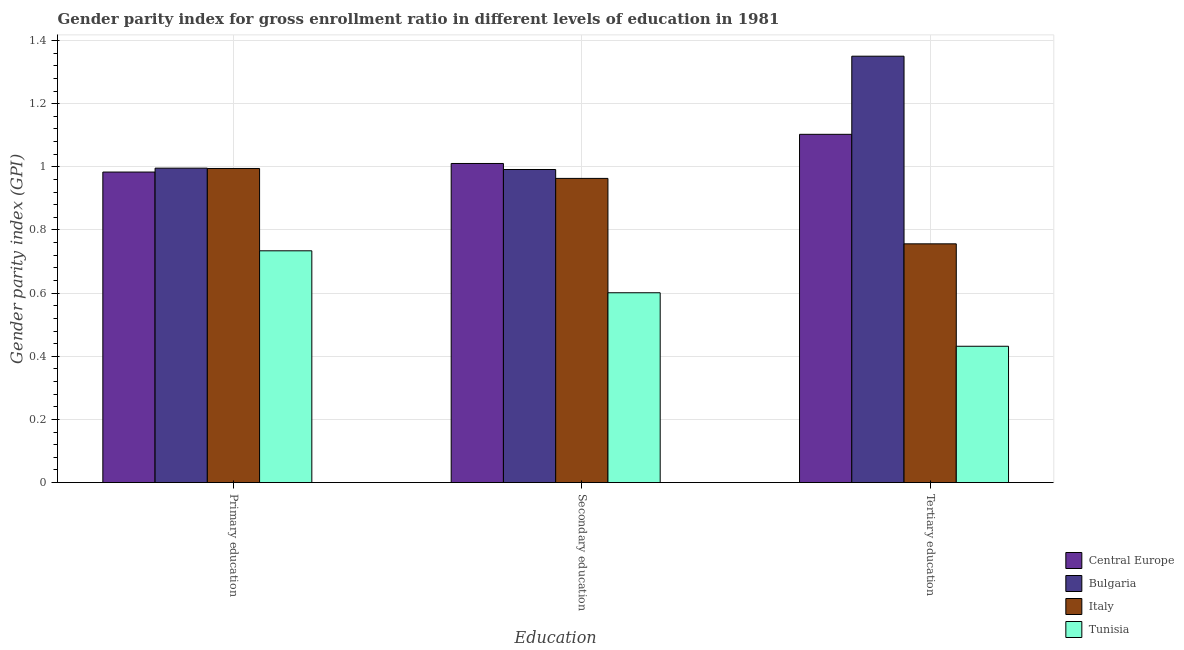How many groups of bars are there?
Provide a succinct answer. 3. Are the number of bars per tick equal to the number of legend labels?
Your answer should be very brief. Yes. How many bars are there on the 3rd tick from the left?
Keep it short and to the point. 4. What is the label of the 3rd group of bars from the left?
Your answer should be very brief. Tertiary education. What is the gender parity index in primary education in Tunisia?
Provide a short and direct response. 0.73. Across all countries, what is the maximum gender parity index in primary education?
Ensure brevity in your answer.  1. Across all countries, what is the minimum gender parity index in tertiary education?
Make the answer very short. 0.43. In which country was the gender parity index in tertiary education minimum?
Provide a succinct answer. Tunisia. What is the total gender parity index in primary education in the graph?
Your answer should be compact. 3.71. What is the difference between the gender parity index in secondary education in Italy and that in Bulgaria?
Offer a terse response. -0.03. What is the difference between the gender parity index in primary education in Bulgaria and the gender parity index in tertiary education in Tunisia?
Your answer should be very brief. 0.56. What is the average gender parity index in tertiary education per country?
Ensure brevity in your answer.  0.91. What is the difference between the gender parity index in tertiary education and gender parity index in primary education in Bulgaria?
Make the answer very short. 0.35. In how many countries, is the gender parity index in secondary education greater than 0.6400000000000001 ?
Offer a terse response. 3. What is the ratio of the gender parity index in tertiary education in Tunisia to that in Italy?
Your answer should be compact. 0.57. Is the difference between the gender parity index in secondary education in Italy and Tunisia greater than the difference between the gender parity index in tertiary education in Italy and Tunisia?
Your answer should be very brief. Yes. What is the difference between the highest and the second highest gender parity index in primary education?
Offer a very short reply. 0. What is the difference between the highest and the lowest gender parity index in primary education?
Your answer should be very brief. 0.26. In how many countries, is the gender parity index in secondary education greater than the average gender parity index in secondary education taken over all countries?
Ensure brevity in your answer.  3. Is the sum of the gender parity index in secondary education in Tunisia and Central Europe greater than the maximum gender parity index in primary education across all countries?
Provide a short and direct response. Yes. What does the 4th bar from the left in Secondary education represents?
Give a very brief answer. Tunisia. What does the 4th bar from the right in Secondary education represents?
Your response must be concise. Central Europe. Is it the case that in every country, the sum of the gender parity index in primary education and gender parity index in secondary education is greater than the gender parity index in tertiary education?
Offer a very short reply. Yes. Are the values on the major ticks of Y-axis written in scientific E-notation?
Offer a terse response. No. Does the graph contain any zero values?
Keep it short and to the point. No. Where does the legend appear in the graph?
Ensure brevity in your answer.  Bottom right. How are the legend labels stacked?
Offer a very short reply. Vertical. What is the title of the graph?
Make the answer very short. Gender parity index for gross enrollment ratio in different levels of education in 1981. Does "Norway" appear as one of the legend labels in the graph?
Provide a succinct answer. No. What is the label or title of the X-axis?
Offer a very short reply. Education. What is the label or title of the Y-axis?
Provide a succinct answer. Gender parity index (GPI). What is the Gender parity index (GPI) in Central Europe in Primary education?
Keep it short and to the point. 0.98. What is the Gender parity index (GPI) in Bulgaria in Primary education?
Provide a short and direct response. 1. What is the Gender parity index (GPI) in Italy in Primary education?
Keep it short and to the point. 0.99. What is the Gender parity index (GPI) of Tunisia in Primary education?
Make the answer very short. 0.73. What is the Gender parity index (GPI) of Central Europe in Secondary education?
Make the answer very short. 1.01. What is the Gender parity index (GPI) in Bulgaria in Secondary education?
Your answer should be compact. 0.99. What is the Gender parity index (GPI) in Italy in Secondary education?
Ensure brevity in your answer.  0.96. What is the Gender parity index (GPI) of Tunisia in Secondary education?
Offer a terse response. 0.6. What is the Gender parity index (GPI) of Central Europe in Tertiary education?
Your answer should be very brief. 1.1. What is the Gender parity index (GPI) in Bulgaria in Tertiary education?
Your answer should be very brief. 1.35. What is the Gender parity index (GPI) in Italy in Tertiary education?
Keep it short and to the point. 0.76. What is the Gender parity index (GPI) of Tunisia in Tertiary education?
Ensure brevity in your answer.  0.43. Across all Education, what is the maximum Gender parity index (GPI) of Central Europe?
Offer a very short reply. 1.1. Across all Education, what is the maximum Gender parity index (GPI) in Bulgaria?
Ensure brevity in your answer.  1.35. Across all Education, what is the maximum Gender parity index (GPI) of Tunisia?
Your response must be concise. 0.73. Across all Education, what is the minimum Gender parity index (GPI) of Central Europe?
Provide a succinct answer. 0.98. Across all Education, what is the minimum Gender parity index (GPI) in Bulgaria?
Ensure brevity in your answer.  0.99. Across all Education, what is the minimum Gender parity index (GPI) of Italy?
Your response must be concise. 0.76. Across all Education, what is the minimum Gender parity index (GPI) in Tunisia?
Provide a succinct answer. 0.43. What is the total Gender parity index (GPI) of Central Europe in the graph?
Your response must be concise. 3.1. What is the total Gender parity index (GPI) in Bulgaria in the graph?
Offer a terse response. 3.34. What is the total Gender parity index (GPI) in Italy in the graph?
Give a very brief answer. 2.71. What is the total Gender parity index (GPI) of Tunisia in the graph?
Provide a short and direct response. 1.77. What is the difference between the Gender parity index (GPI) in Central Europe in Primary education and that in Secondary education?
Provide a succinct answer. -0.03. What is the difference between the Gender parity index (GPI) of Bulgaria in Primary education and that in Secondary education?
Your response must be concise. 0. What is the difference between the Gender parity index (GPI) in Italy in Primary education and that in Secondary education?
Your answer should be very brief. 0.03. What is the difference between the Gender parity index (GPI) of Tunisia in Primary education and that in Secondary education?
Offer a terse response. 0.13. What is the difference between the Gender parity index (GPI) in Central Europe in Primary education and that in Tertiary education?
Ensure brevity in your answer.  -0.12. What is the difference between the Gender parity index (GPI) in Bulgaria in Primary education and that in Tertiary education?
Your response must be concise. -0.35. What is the difference between the Gender parity index (GPI) in Italy in Primary education and that in Tertiary education?
Provide a succinct answer. 0.24. What is the difference between the Gender parity index (GPI) of Tunisia in Primary education and that in Tertiary education?
Ensure brevity in your answer.  0.3. What is the difference between the Gender parity index (GPI) in Central Europe in Secondary education and that in Tertiary education?
Keep it short and to the point. -0.09. What is the difference between the Gender parity index (GPI) in Bulgaria in Secondary education and that in Tertiary education?
Offer a very short reply. -0.36. What is the difference between the Gender parity index (GPI) in Italy in Secondary education and that in Tertiary education?
Your answer should be compact. 0.21. What is the difference between the Gender parity index (GPI) in Tunisia in Secondary education and that in Tertiary education?
Provide a short and direct response. 0.17. What is the difference between the Gender parity index (GPI) in Central Europe in Primary education and the Gender parity index (GPI) in Bulgaria in Secondary education?
Provide a short and direct response. -0.01. What is the difference between the Gender parity index (GPI) of Central Europe in Primary education and the Gender parity index (GPI) of Italy in Secondary education?
Give a very brief answer. 0.02. What is the difference between the Gender parity index (GPI) in Central Europe in Primary education and the Gender parity index (GPI) in Tunisia in Secondary education?
Your answer should be very brief. 0.38. What is the difference between the Gender parity index (GPI) in Bulgaria in Primary education and the Gender parity index (GPI) in Italy in Secondary education?
Provide a short and direct response. 0.03. What is the difference between the Gender parity index (GPI) of Bulgaria in Primary education and the Gender parity index (GPI) of Tunisia in Secondary education?
Make the answer very short. 0.39. What is the difference between the Gender parity index (GPI) in Italy in Primary education and the Gender parity index (GPI) in Tunisia in Secondary education?
Give a very brief answer. 0.39. What is the difference between the Gender parity index (GPI) in Central Europe in Primary education and the Gender parity index (GPI) in Bulgaria in Tertiary education?
Your answer should be compact. -0.37. What is the difference between the Gender parity index (GPI) in Central Europe in Primary education and the Gender parity index (GPI) in Italy in Tertiary education?
Make the answer very short. 0.23. What is the difference between the Gender parity index (GPI) of Central Europe in Primary education and the Gender parity index (GPI) of Tunisia in Tertiary education?
Keep it short and to the point. 0.55. What is the difference between the Gender parity index (GPI) in Bulgaria in Primary education and the Gender parity index (GPI) in Italy in Tertiary education?
Give a very brief answer. 0.24. What is the difference between the Gender parity index (GPI) in Bulgaria in Primary education and the Gender parity index (GPI) in Tunisia in Tertiary education?
Keep it short and to the point. 0.56. What is the difference between the Gender parity index (GPI) of Italy in Primary education and the Gender parity index (GPI) of Tunisia in Tertiary education?
Your answer should be compact. 0.56. What is the difference between the Gender parity index (GPI) in Central Europe in Secondary education and the Gender parity index (GPI) in Bulgaria in Tertiary education?
Your response must be concise. -0.34. What is the difference between the Gender parity index (GPI) in Central Europe in Secondary education and the Gender parity index (GPI) in Italy in Tertiary education?
Offer a terse response. 0.25. What is the difference between the Gender parity index (GPI) in Central Europe in Secondary education and the Gender parity index (GPI) in Tunisia in Tertiary education?
Ensure brevity in your answer.  0.58. What is the difference between the Gender parity index (GPI) of Bulgaria in Secondary education and the Gender parity index (GPI) of Italy in Tertiary education?
Offer a very short reply. 0.24. What is the difference between the Gender parity index (GPI) of Bulgaria in Secondary education and the Gender parity index (GPI) of Tunisia in Tertiary education?
Offer a very short reply. 0.56. What is the difference between the Gender parity index (GPI) of Italy in Secondary education and the Gender parity index (GPI) of Tunisia in Tertiary education?
Offer a terse response. 0.53. What is the average Gender parity index (GPI) of Central Europe per Education?
Give a very brief answer. 1.03. What is the average Gender parity index (GPI) of Bulgaria per Education?
Keep it short and to the point. 1.11. What is the average Gender parity index (GPI) of Italy per Education?
Offer a very short reply. 0.9. What is the average Gender parity index (GPI) in Tunisia per Education?
Keep it short and to the point. 0.59. What is the difference between the Gender parity index (GPI) in Central Europe and Gender parity index (GPI) in Bulgaria in Primary education?
Make the answer very short. -0.01. What is the difference between the Gender parity index (GPI) of Central Europe and Gender parity index (GPI) of Italy in Primary education?
Give a very brief answer. -0.01. What is the difference between the Gender parity index (GPI) of Central Europe and Gender parity index (GPI) of Tunisia in Primary education?
Keep it short and to the point. 0.25. What is the difference between the Gender parity index (GPI) in Bulgaria and Gender parity index (GPI) in Italy in Primary education?
Your answer should be very brief. 0. What is the difference between the Gender parity index (GPI) in Bulgaria and Gender parity index (GPI) in Tunisia in Primary education?
Keep it short and to the point. 0.26. What is the difference between the Gender parity index (GPI) of Italy and Gender parity index (GPI) of Tunisia in Primary education?
Make the answer very short. 0.26. What is the difference between the Gender parity index (GPI) in Central Europe and Gender parity index (GPI) in Bulgaria in Secondary education?
Provide a short and direct response. 0.02. What is the difference between the Gender parity index (GPI) of Central Europe and Gender parity index (GPI) of Italy in Secondary education?
Provide a short and direct response. 0.05. What is the difference between the Gender parity index (GPI) of Central Europe and Gender parity index (GPI) of Tunisia in Secondary education?
Offer a very short reply. 0.41. What is the difference between the Gender parity index (GPI) in Bulgaria and Gender parity index (GPI) in Italy in Secondary education?
Your answer should be very brief. 0.03. What is the difference between the Gender parity index (GPI) of Bulgaria and Gender parity index (GPI) of Tunisia in Secondary education?
Provide a short and direct response. 0.39. What is the difference between the Gender parity index (GPI) of Italy and Gender parity index (GPI) of Tunisia in Secondary education?
Your answer should be very brief. 0.36. What is the difference between the Gender parity index (GPI) of Central Europe and Gender parity index (GPI) of Bulgaria in Tertiary education?
Your answer should be compact. -0.25. What is the difference between the Gender parity index (GPI) in Central Europe and Gender parity index (GPI) in Italy in Tertiary education?
Offer a terse response. 0.35. What is the difference between the Gender parity index (GPI) of Central Europe and Gender parity index (GPI) of Tunisia in Tertiary education?
Keep it short and to the point. 0.67. What is the difference between the Gender parity index (GPI) in Bulgaria and Gender parity index (GPI) in Italy in Tertiary education?
Ensure brevity in your answer.  0.59. What is the difference between the Gender parity index (GPI) of Bulgaria and Gender parity index (GPI) of Tunisia in Tertiary education?
Offer a terse response. 0.92. What is the difference between the Gender parity index (GPI) in Italy and Gender parity index (GPI) in Tunisia in Tertiary education?
Keep it short and to the point. 0.32. What is the ratio of the Gender parity index (GPI) of Central Europe in Primary education to that in Secondary education?
Your answer should be very brief. 0.97. What is the ratio of the Gender parity index (GPI) in Italy in Primary education to that in Secondary education?
Your answer should be compact. 1.03. What is the ratio of the Gender parity index (GPI) in Tunisia in Primary education to that in Secondary education?
Offer a terse response. 1.22. What is the ratio of the Gender parity index (GPI) in Central Europe in Primary education to that in Tertiary education?
Your response must be concise. 0.89. What is the ratio of the Gender parity index (GPI) of Bulgaria in Primary education to that in Tertiary education?
Provide a short and direct response. 0.74. What is the ratio of the Gender parity index (GPI) in Italy in Primary education to that in Tertiary education?
Give a very brief answer. 1.32. What is the ratio of the Gender parity index (GPI) in Tunisia in Primary education to that in Tertiary education?
Ensure brevity in your answer.  1.7. What is the ratio of the Gender parity index (GPI) in Central Europe in Secondary education to that in Tertiary education?
Your answer should be very brief. 0.92. What is the ratio of the Gender parity index (GPI) in Bulgaria in Secondary education to that in Tertiary education?
Make the answer very short. 0.73. What is the ratio of the Gender parity index (GPI) of Italy in Secondary education to that in Tertiary education?
Offer a terse response. 1.27. What is the ratio of the Gender parity index (GPI) in Tunisia in Secondary education to that in Tertiary education?
Keep it short and to the point. 1.39. What is the difference between the highest and the second highest Gender parity index (GPI) in Central Europe?
Give a very brief answer. 0.09. What is the difference between the highest and the second highest Gender parity index (GPI) in Bulgaria?
Provide a succinct answer. 0.35. What is the difference between the highest and the second highest Gender parity index (GPI) in Italy?
Keep it short and to the point. 0.03. What is the difference between the highest and the second highest Gender parity index (GPI) of Tunisia?
Your response must be concise. 0.13. What is the difference between the highest and the lowest Gender parity index (GPI) in Central Europe?
Your answer should be compact. 0.12. What is the difference between the highest and the lowest Gender parity index (GPI) of Bulgaria?
Keep it short and to the point. 0.36. What is the difference between the highest and the lowest Gender parity index (GPI) in Italy?
Make the answer very short. 0.24. What is the difference between the highest and the lowest Gender parity index (GPI) of Tunisia?
Keep it short and to the point. 0.3. 